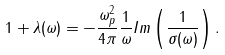<formula> <loc_0><loc_0><loc_500><loc_500>1 + \lambda ( \omega ) = - \frac { \omega _ { p } ^ { 2 } } { 4 \pi } \frac { 1 } { \omega } I m \left ( \frac { 1 } { \sigma ( \omega ) } \right ) .</formula> 